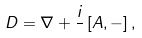<formula> <loc_0><loc_0><loc_500><loc_500>D = \nabla + \frac { i } { } \left [ A , - \right ] ,</formula> 